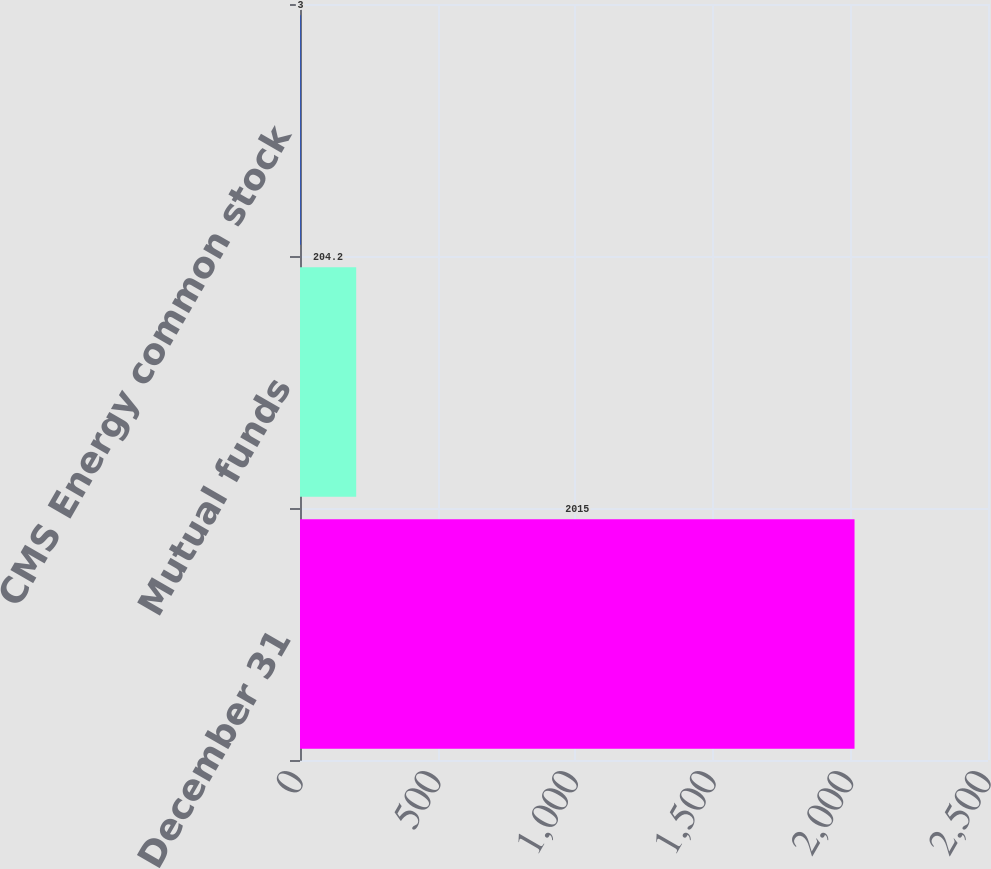<chart> <loc_0><loc_0><loc_500><loc_500><bar_chart><fcel>December 31<fcel>Mutual funds<fcel>CMS Energy common stock<nl><fcel>2015<fcel>204.2<fcel>3<nl></chart> 